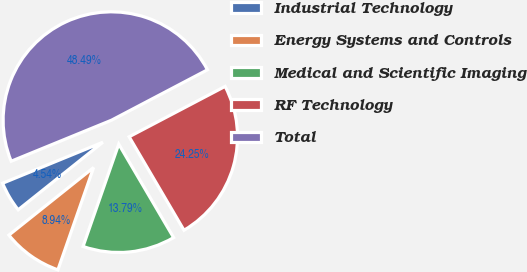Convert chart to OTSL. <chart><loc_0><loc_0><loc_500><loc_500><pie_chart><fcel>Industrial Technology<fcel>Energy Systems and Controls<fcel>Medical and Scientific Imaging<fcel>RF Technology<fcel>Total<nl><fcel>4.54%<fcel>8.94%<fcel>13.79%<fcel>24.25%<fcel>48.49%<nl></chart> 